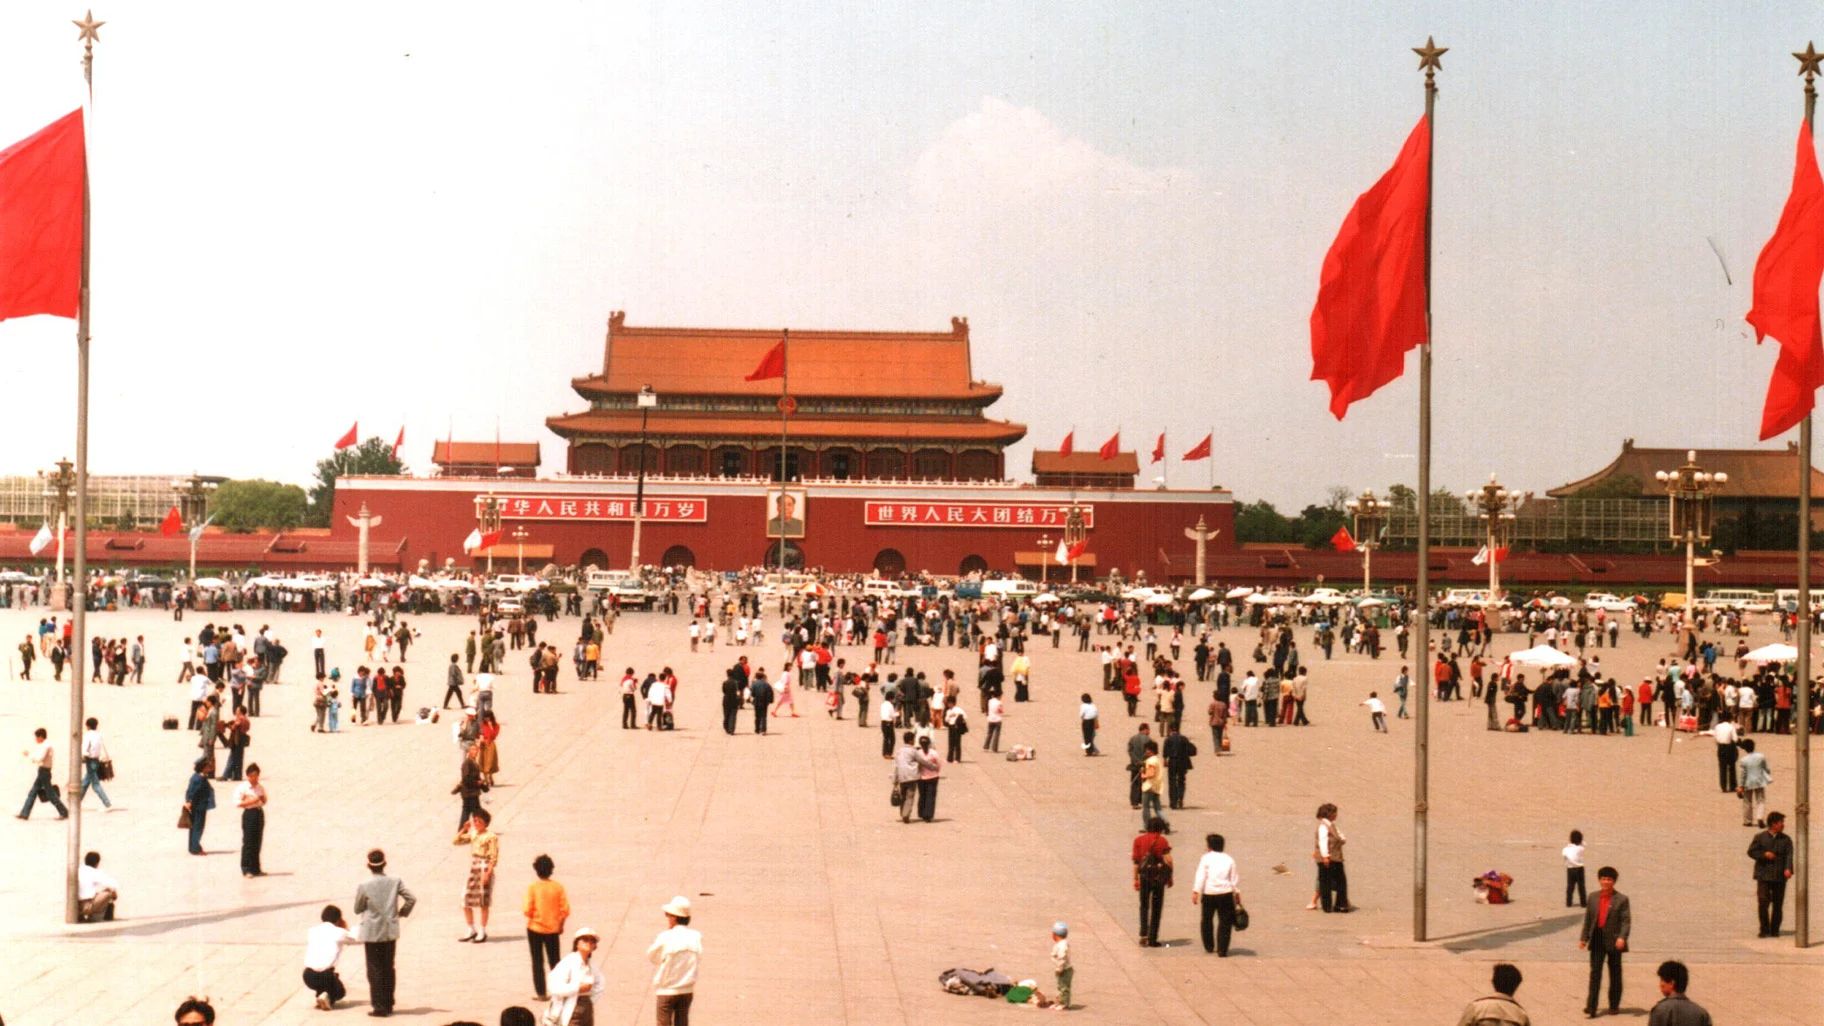What's the historical significance of this location? Tiananmen Square is one of the largest public squares in the world and holds great historical and cultural importance in China. It has been the site of numerous significant events in Chinese history, including the May Fourth Movement in 1919 and the declaration of the People's Republic of China by Mao Zedong in 1949. The square is also known for the 1989 pro-democracy protests and the subsequent military crackdown. It serves as an important symbol of political power and the enduring spirit of the Chinese people. 